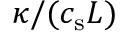<formula> <loc_0><loc_0><loc_500><loc_500>\kappa / ( c _ { s } L )</formula> 